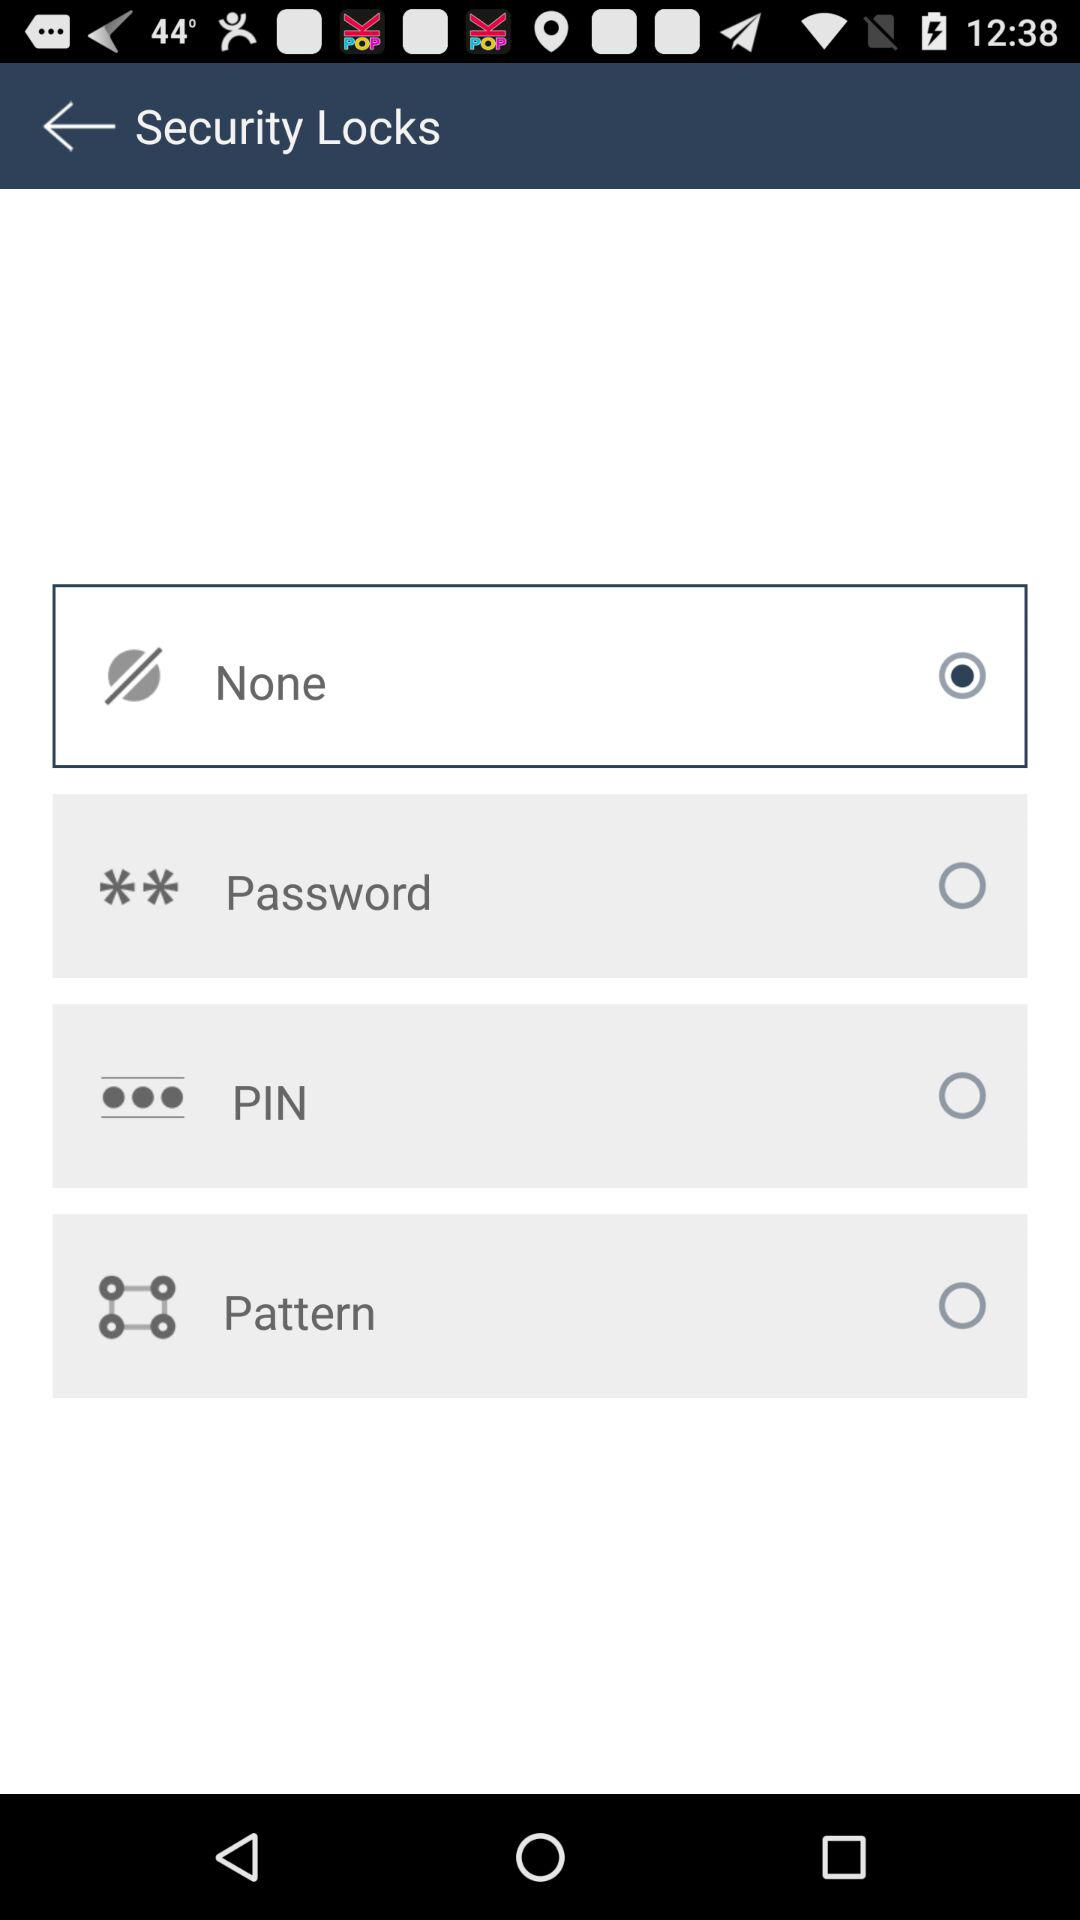Which option has been selected for "Security Locks"? The selected option is "None". 